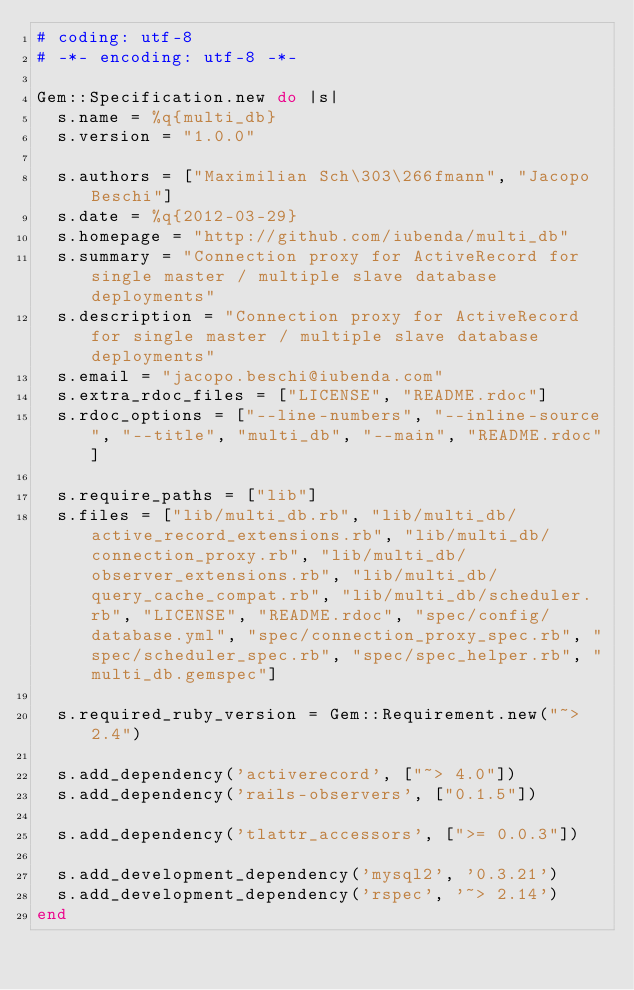<code> <loc_0><loc_0><loc_500><loc_500><_Ruby_># coding: utf-8
# -*- encoding: utf-8 -*-

Gem::Specification.new do |s|
  s.name = %q{multi_db}
  s.version = "1.0.0"

  s.authors = ["Maximilian Sch\303\266fmann", "Jacopo Beschi"]
  s.date = %q{2012-03-29}
  s.homepage = "http://github.com/iubenda/multi_db"
  s.summary = "Connection proxy for ActiveRecord for single master / multiple slave database deployments"
  s.description = "Connection proxy for ActiveRecord for single master / multiple slave database deployments"
  s.email = "jacopo.beschi@iubenda.com"
  s.extra_rdoc_files = ["LICENSE", "README.rdoc"]
  s.rdoc_options = ["--line-numbers", "--inline-source", "--title", "multi_db", "--main", "README.rdoc"]

  s.require_paths = ["lib"]
  s.files = ["lib/multi_db.rb", "lib/multi_db/active_record_extensions.rb", "lib/multi_db/connection_proxy.rb", "lib/multi_db/observer_extensions.rb", "lib/multi_db/query_cache_compat.rb", "lib/multi_db/scheduler.rb", "LICENSE", "README.rdoc", "spec/config/database.yml", "spec/connection_proxy_spec.rb", "spec/scheduler_spec.rb", "spec/spec_helper.rb", "multi_db.gemspec"]

  s.required_ruby_version = Gem::Requirement.new("~> 2.4")

  s.add_dependency('activerecord', ["~> 4.0"])
  s.add_dependency('rails-observers', ["0.1.5"])

  s.add_dependency('tlattr_accessors', [">= 0.0.3"])

  s.add_development_dependency('mysql2', '0.3.21')
  s.add_development_dependency('rspec', '~> 2.14')
end
</code> 